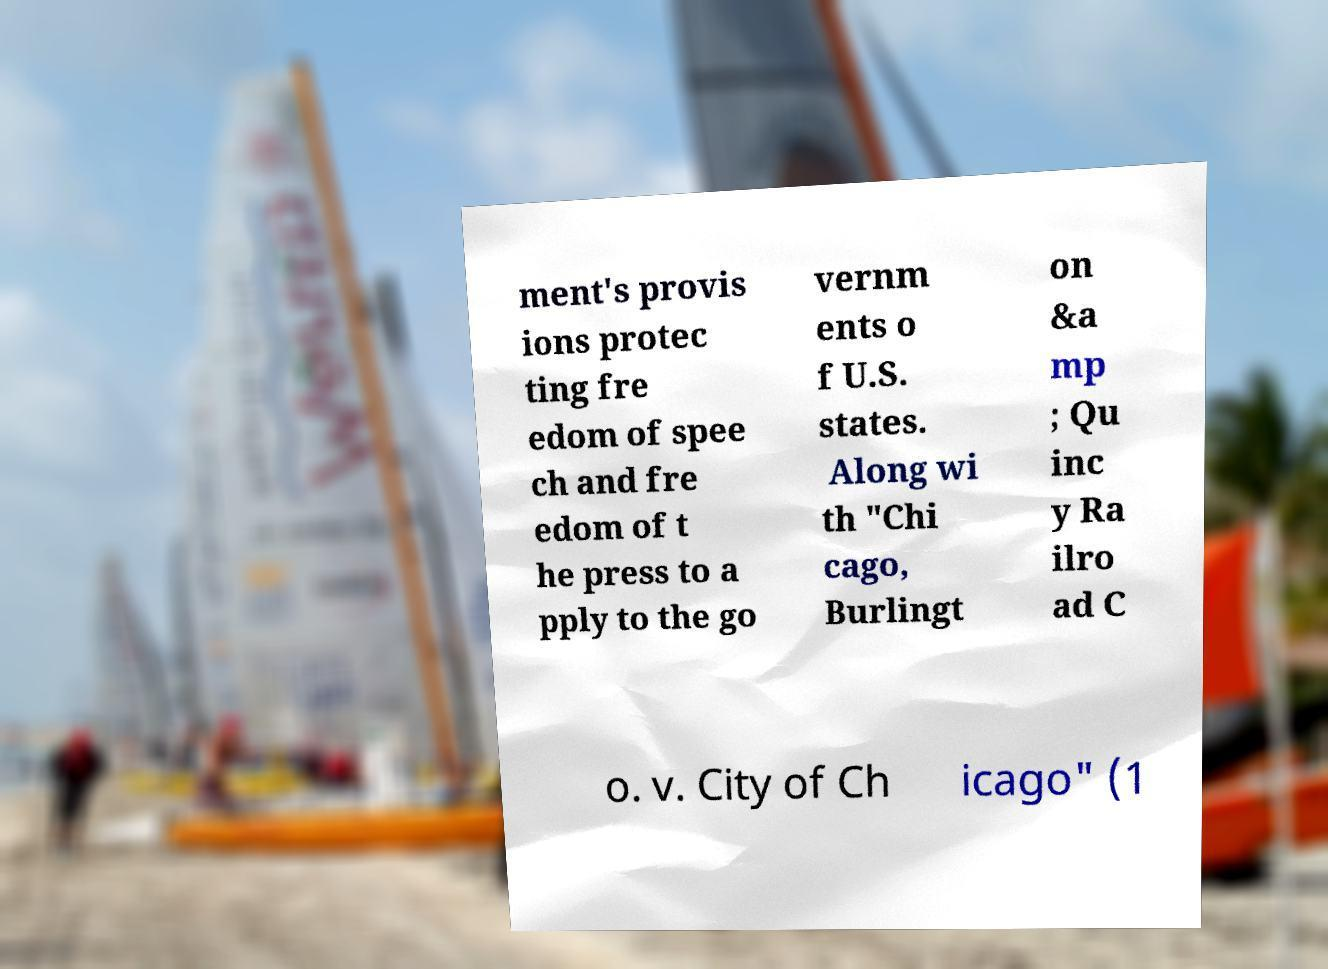Can you accurately transcribe the text from the provided image for me? ment's provis ions protec ting fre edom of spee ch and fre edom of t he press to a pply to the go vernm ents o f U.S. states. Along wi th "Chi cago, Burlingt on &a mp ; Qu inc y Ra ilro ad C o. v. City of Ch icago" (1 